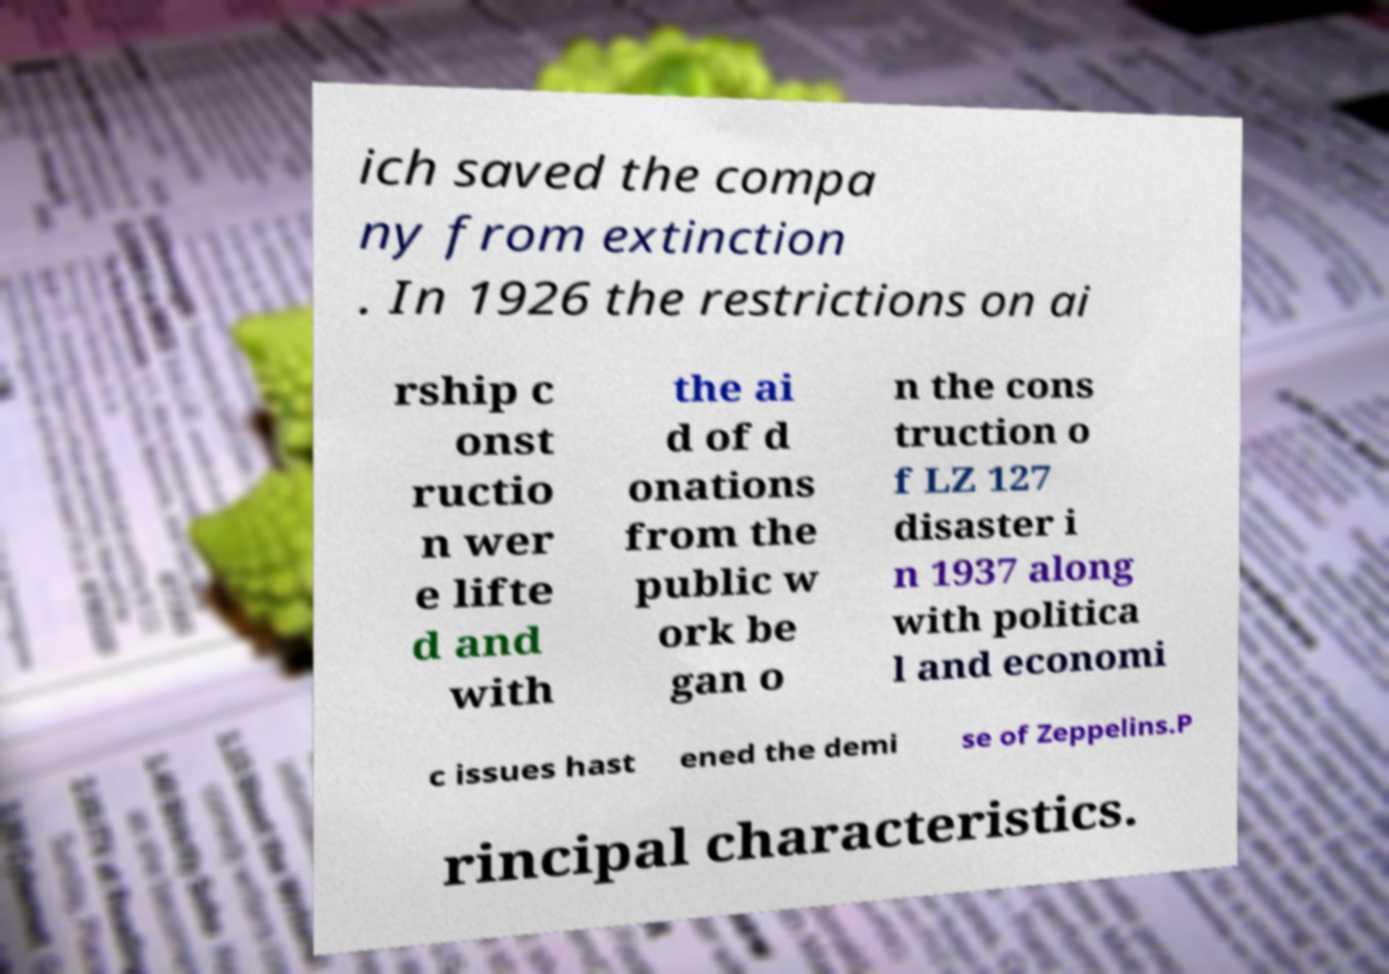Could you extract and type out the text from this image? ich saved the compa ny from extinction . In 1926 the restrictions on ai rship c onst ructio n wer e lifte d and with the ai d of d onations from the public w ork be gan o n the cons truction o f LZ 127 disaster i n 1937 along with politica l and economi c issues hast ened the demi se of Zeppelins.P rincipal characteristics. 